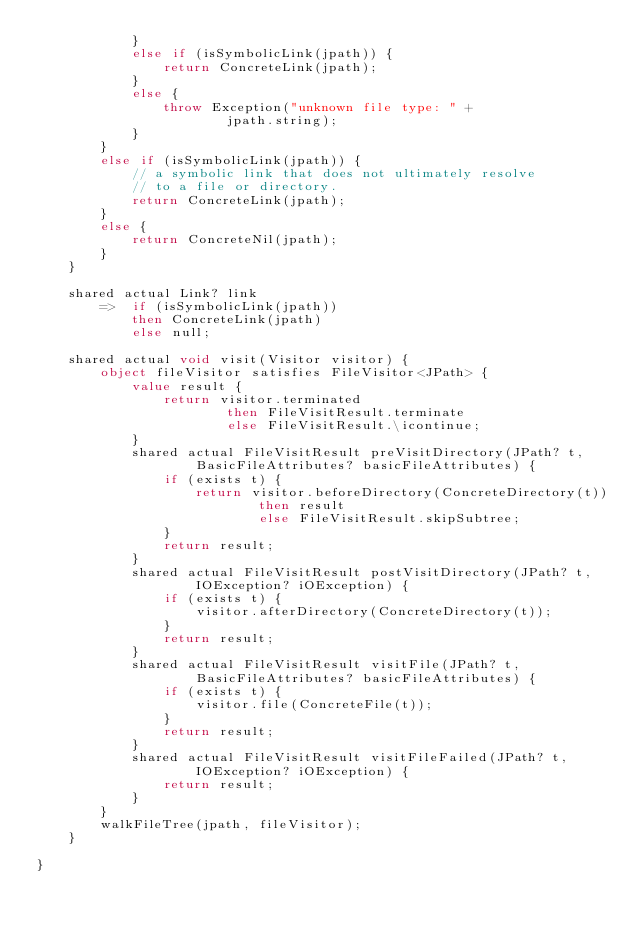Convert code to text. <code><loc_0><loc_0><loc_500><loc_500><_Ceylon_>            }
            else if (isSymbolicLink(jpath)) {
                return ConcreteLink(jpath);
            }
            else {
                throw Exception("unknown file type: " +
                        jpath.string);
            }
        }
        else if (isSymbolicLink(jpath)) {
            // a symbolic link that does not ultimately resolve
            // to a file or directory.
            return ConcreteLink(jpath);
        }
        else {
            return ConcreteNil(jpath);
        }
    }
    
    shared actual Link? link
        =>  if (isSymbolicLink(jpath))
            then ConcreteLink(jpath)
            else null;
    
    shared actual void visit(Visitor visitor) {
        object fileVisitor satisfies FileVisitor<JPath> {
            value result {
                return visitor.terminated 
                        then FileVisitResult.terminate
                        else FileVisitResult.\icontinue;
            }
            shared actual FileVisitResult preVisitDirectory(JPath? t, 
                    BasicFileAttributes? basicFileAttributes) {
                if (exists t) {
                    return visitor.beforeDirectory(ConcreteDirectory(t)) 
                            then result
                            else FileVisitResult.skipSubtree;
                }
                return result;
            }
            shared actual FileVisitResult postVisitDirectory(JPath? t, 
                    IOException? iOException) {
                if (exists t) {
                    visitor.afterDirectory(ConcreteDirectory(t));
                }
                return result;
            }
            shared actual FileVisitResult visitFile(JPath? t, 
                    BasicFileAttributes? basicFileAttributes) {
                if (exists t) {
                    visitor.file(ConcreteFile(t));
                }
                return result;
            }
            shared actual FileVisitResult visitFileFailed(JPath? t, 
                    IOException? iOException) {
                return result;
            }
        }
        walkFileTree(jpath, fileVisitor);
    }    
    
}
</code> 